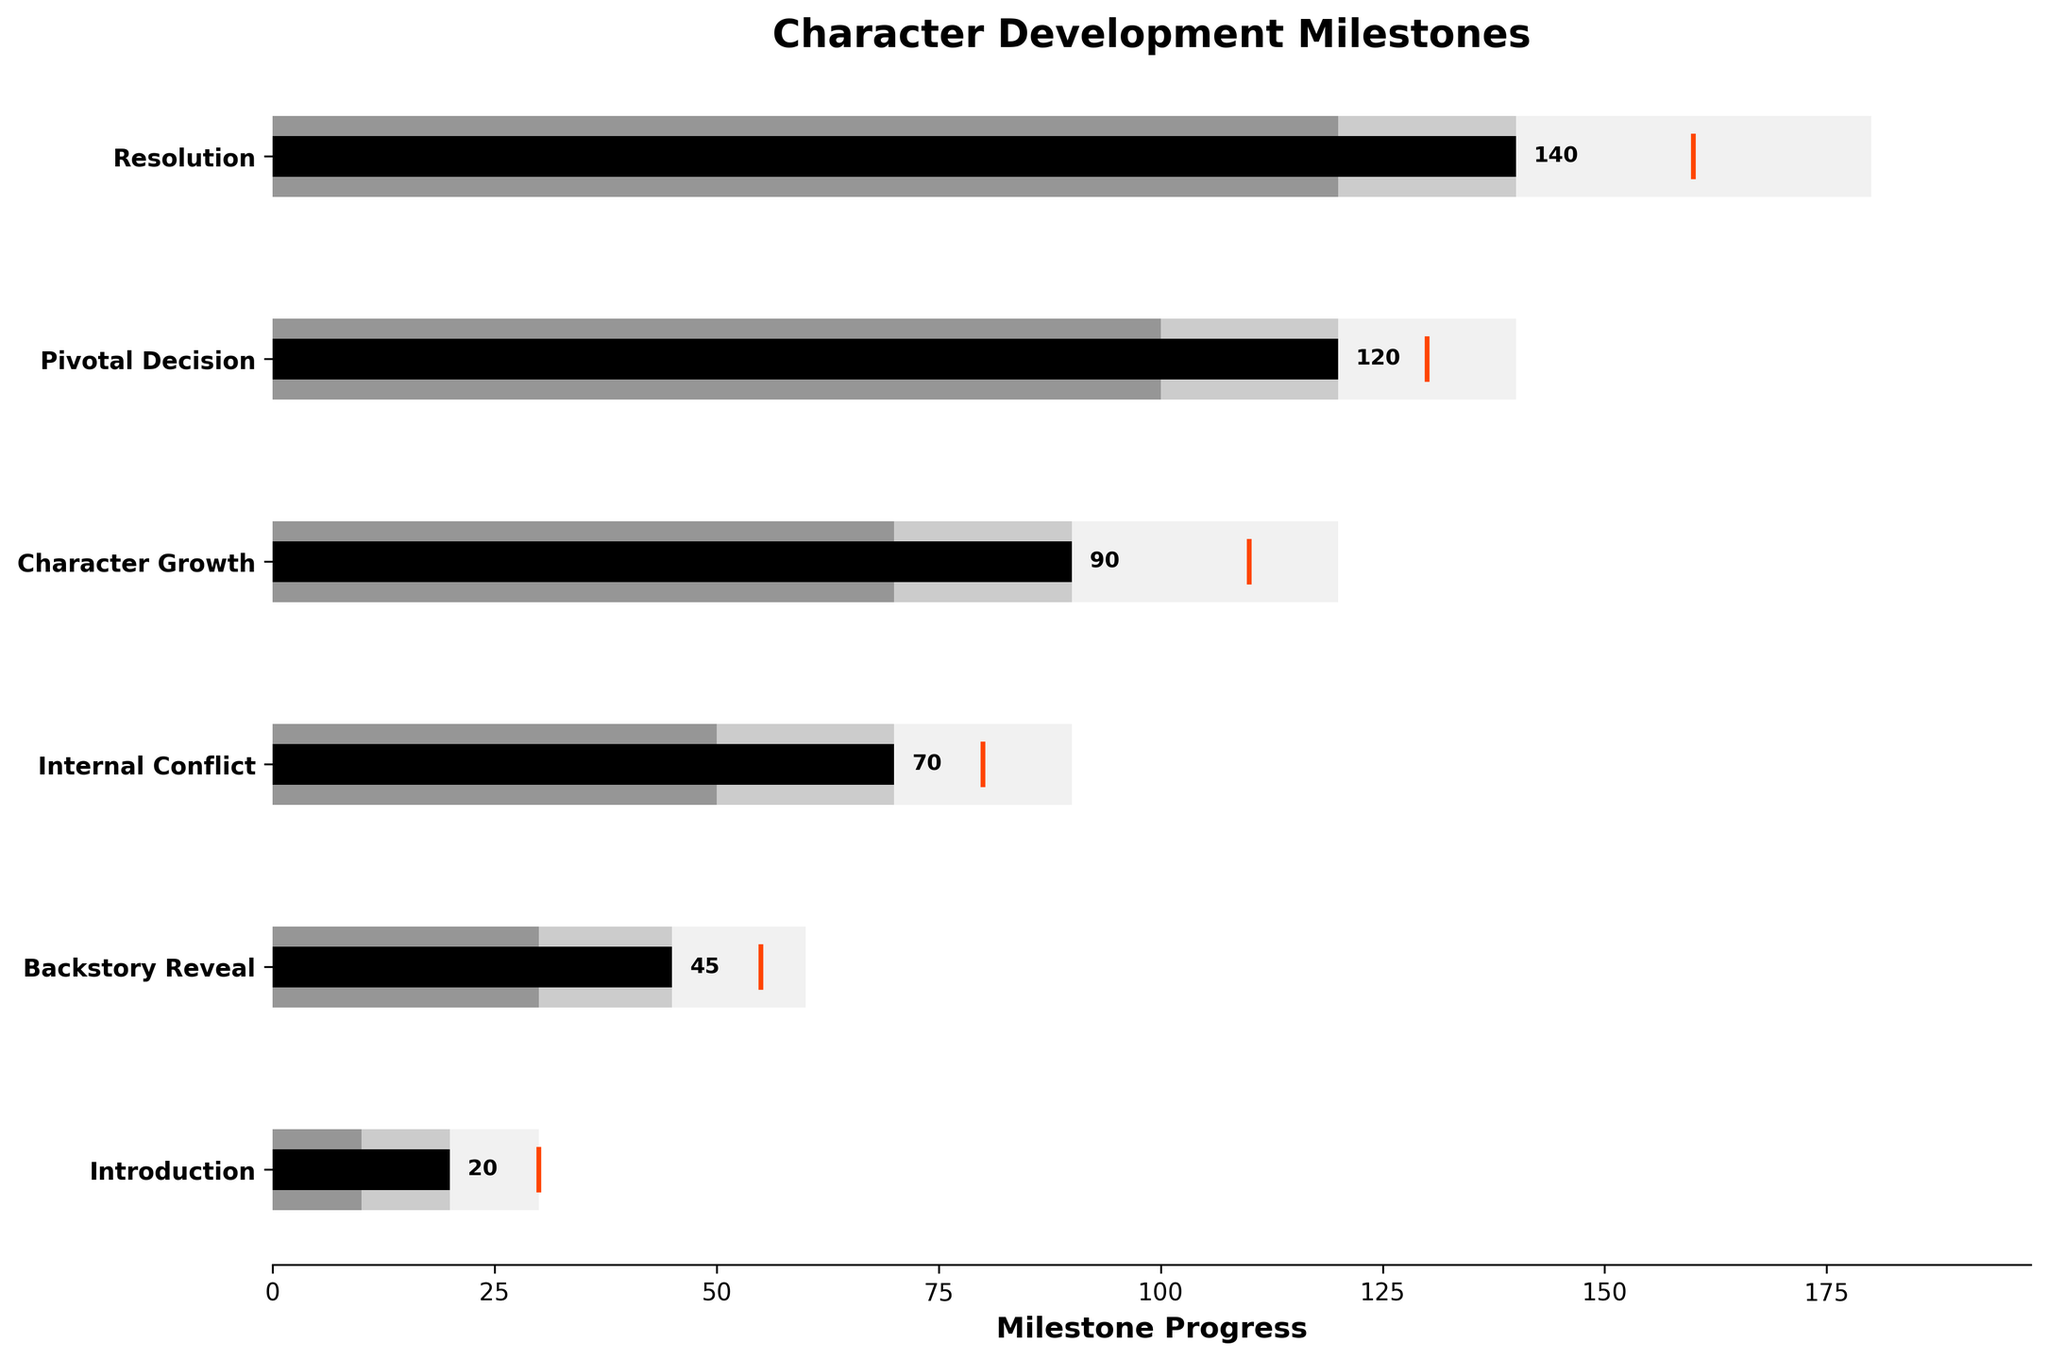Who is the character with the highest progress? By looking at the lengths of the progress bars, the character with the highest bar length is 'Resolution' with a progress of 140.
Answer: Resolution What is the title of the plot? The title is located at the top of the plot and reads "Character Development Milestones."
Answer: Character Development Milestones How many character milestones are represented in the chart? By counting the number of bars or characters listed on the y-axis, we see there are six character milestones.
Answer: 6 Which character milestone is closest to its target progress? By comparing the progress bars to the target lines, 'Character Growth' with a progress of 90 is closest to its target of 100.
Answer: Character Growth What is the range of progress for the 'Internal Conflict' milestone? The range for 'Internal Conflict' includes three layers: 50 (range1), 70 (range2), and 90 (range3).
Answer: 50 to 90 Which character milestone has the greatest difference between its progress and target? By comparing the differences for each character milestone: 
Introduction: 30 - 20 = 10
Backstory Reveal: 55 - 45 = 10
Internal Conflict: 80 - 70 = 10
Character Growth: 110 - 90 = 20
Pivotal Decision: 130 - 120 = 10
Resolution: 160 - 140 = 20
'Character Growth' and 'Resolution' both have a difference of 20, making them the largest.
Answer: Character Growth and Resolution What is the average target value of all character milestones? Sum the target values (30 + 55 + 80 + 110 + 130 + 160 = 565) and divide by the number of milestones (6). The average is 565/6 = 94.17.
Answer: 94.17 Which character has the lowest value in the second range (Range2)? By comparing the second range values for each character milestone: 
Introduction: 20 
Backstory Reveal: 45
Internal Conflict: 70
Character Growth: 90
Pivotal Decision: 120
Resolution: 140
The 'Introduction' has the lowest Range2 value at 20.
Answer: Introduction 